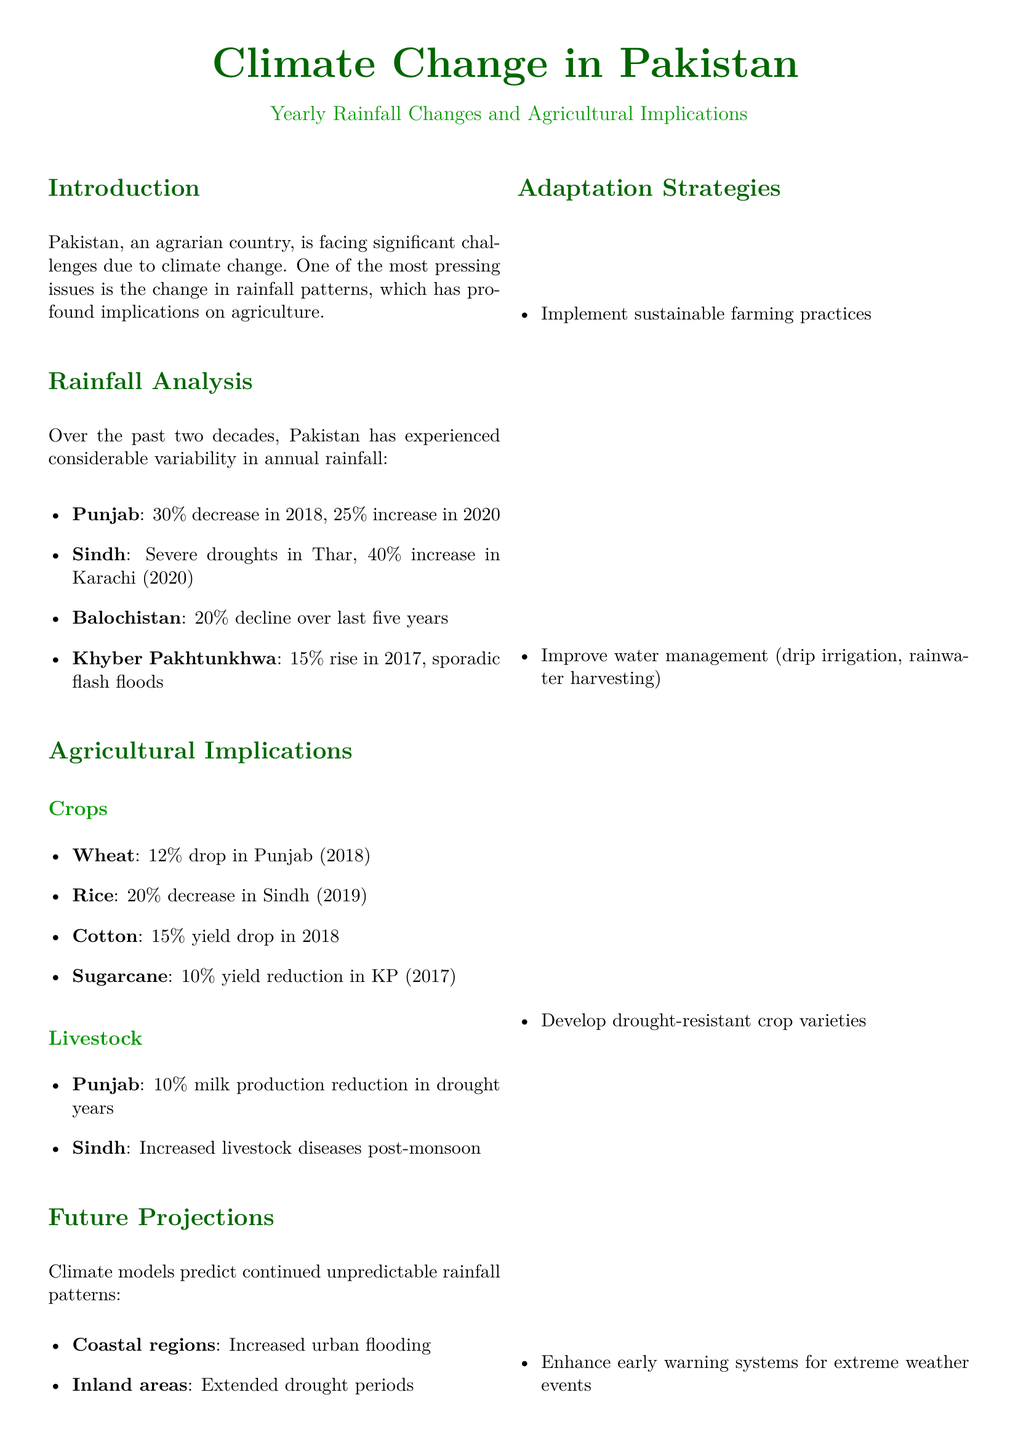What is the percentage decrease in rainfall for Punjab in 2018? The document states there was a 30% decrease in rainfall in Punjab in 2018.
Answer: 30% What was the percentage increase in rainfall for Karachi in 2020? The report mentions a 40% increase in rainfall in Karachi in 2020.
Answer: 40% Which crop experienced a 20% decrease in Sindh in 2019? According to the document, rice saw a 20% decrease in Sindh in 2019.
Answer: Rice What decline in rainfall has Balochistan faced over the last five years? The document indicates a 20% decline in rainfall in Balochistan over the last five years.
Answer: 20% What is a suggested adaptation strategy for climate change in agriculture? The document lists implementing sustainable farming practices as one of the adaptation strategies.
Answer: Sustainable farming What percentage drop in wheat production occurred in Punjab in 2018? The document specifies a 12% drop in wheat production in Punjab in 2018.
Answer: 12% What type of livestock issue is reported post-monsoon in Sindh? The report states there are increased livestock diseases in Sindh post-monsoon.
Answer: Livestock diseases What prediction is made for coastal regions regarding rainfall patterns? The document predicts increased urban flooding for coastal regions due to rainfall pattern changes.
Answer: Increased urban flooding What is the impact of rainfall changes on sugarcane yield in Khyber Pakhtunkhwa? The report indicates a 10% yield reduction in sugarcane in Khyber Pakhtunkhwa in 2017.
Answer: 10% 